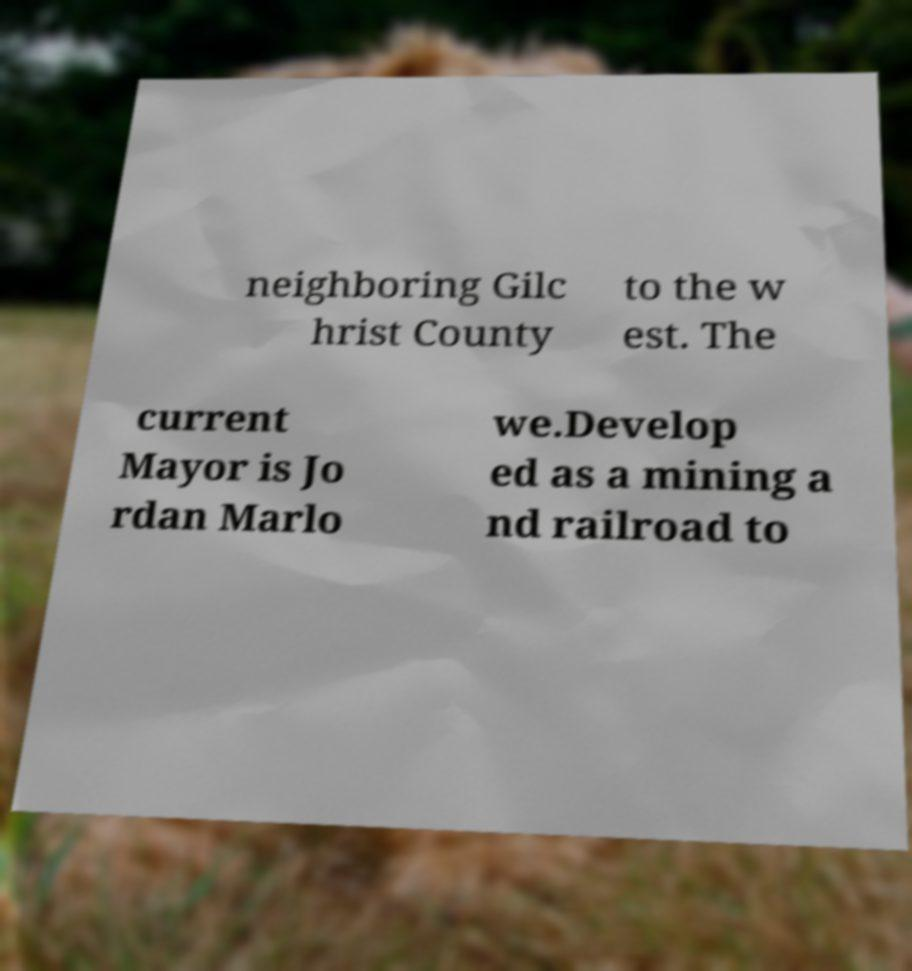Please identify and transcribe the text found in this image. neighboring Gilc hrist County to the w est. The current Mayor is Jo rdan Marlo we.Develop ed as a mining a nd railroad to 